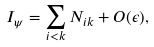<formula> <loc_0><loc_0><loc_500><loc_500>I _ { \psi } = \sum _ { i < k } N _ { i k } + O ( \epsilon ) ,</formula> 